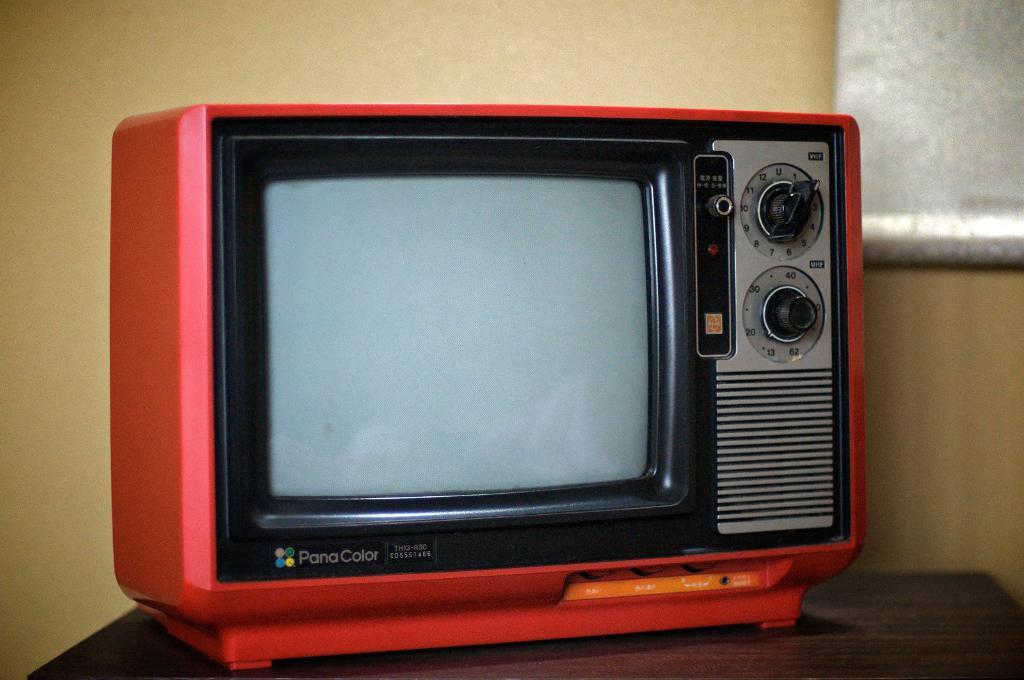What brand is this tv?
Your answer should be compact. Pana color. 